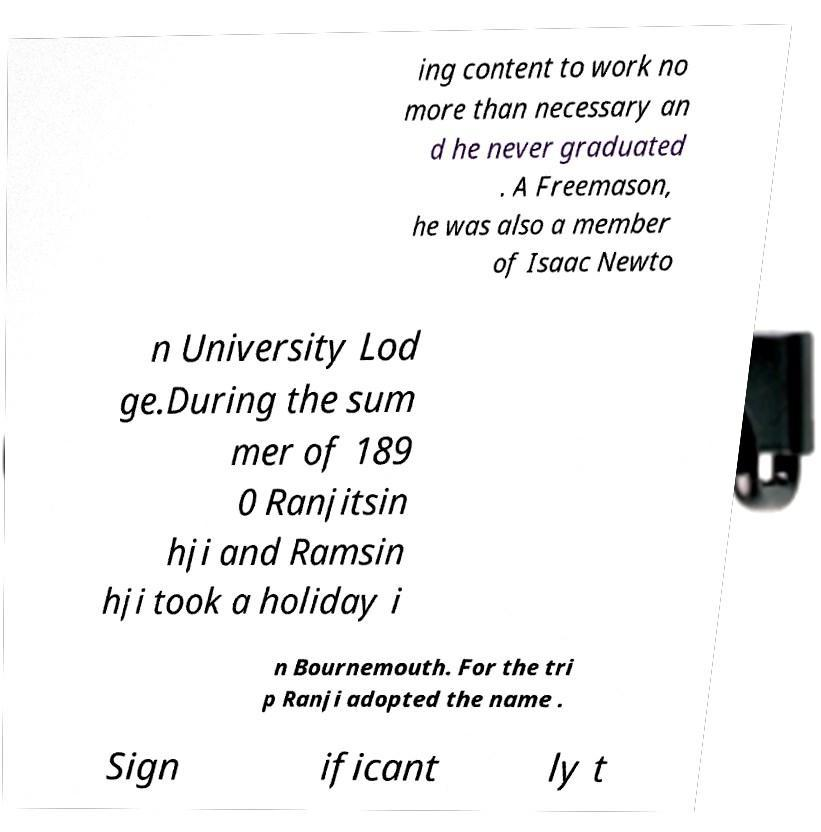Can you read and provide the text displayed in the image?This photo seems to have some interesting text. Can you extract and type it out for me? ing content to work no more than necessary an d he never graduated . A Freemason, he was also a member of Isaac Newto n University Lod ge.During the sum mer of 189 0 Ranjitsin hji and Ramsin hji took a holiday i n Bournemouth. For the tri p Ranji adopted the name . Sign ificant ly t 